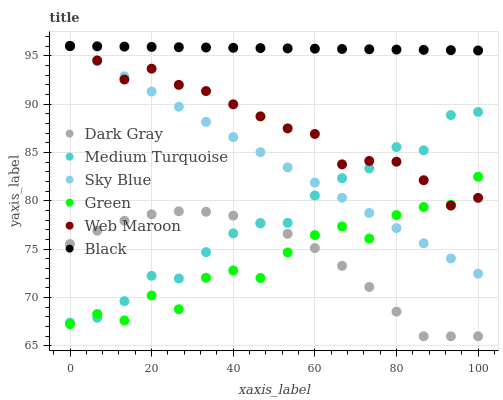Does Green have the minimum area under the curve?
Answer yes or no. Yes. Does Black have the maximum area under the curve?
Answer yes or no. Yes. Does Web Maroon have the minimum area under the curve?
Answer yes or no. No. Does Web Maroon have the maximum area under the curve?
Answer yes or no. No. Is Black the smoothest?
Answer yes or no. Yes. Is Green the roughest?
Answer yes or no. Yes. Is Web Maroon the smoothest?
Answer yes or no. No. Is Web Maroon the roughest?
Answer yes or no. No. Does Dark Gray have the lowest value?
Answer yes or no. Yes. Does Web Maroon have the lowest value?
Answer yes or no. No. Does Sky Blue have the highest value?
Answer yes or no. Yes. Does Dark Gray have the highest value?
Answer yes or no. No. Is Dark Gray less than Web Maroon?
Answer yes or no. Yes. Is Black greater than Dark Gray?
Answer yes or no. Yes. Does Dark Gray intersect Medium Turquoise?
Answer yes or no. Yes. Is Dark Gray less than Medium Turquoise?
Answer yes or no. No. Is Dark Gray greater than Medium Turquoise?
Answer yes or no. No. Does Dark Gray intersect Web Maroon?
Answer yes or no. No. 